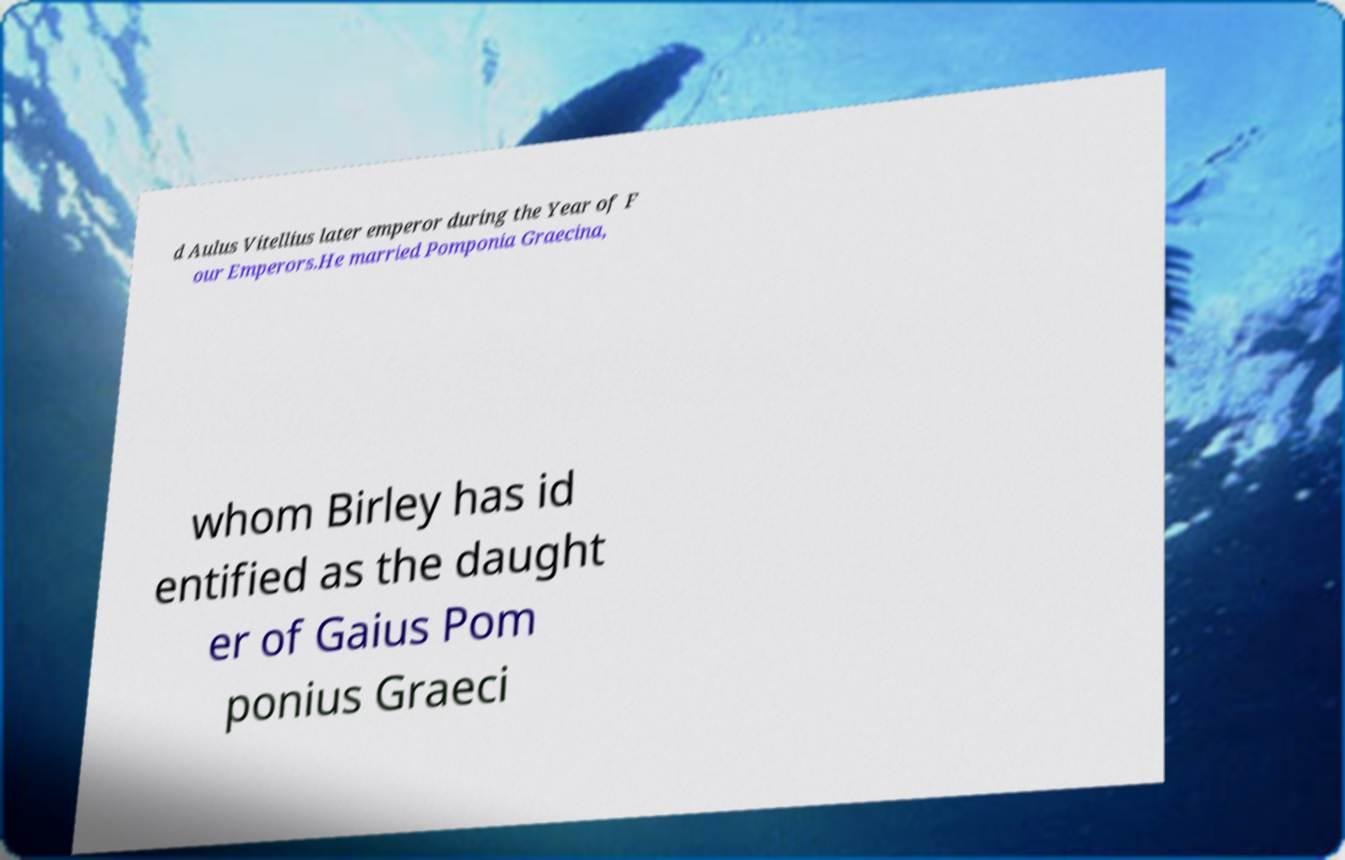Please read and relay the text visible in this image. What does it say? d Aulus Vitellius later emperor during the Year of F our Emperors.He married Pomponia Graecina, whom Birley has id entified as the daught er of Gaius Pom ponius Graeci 